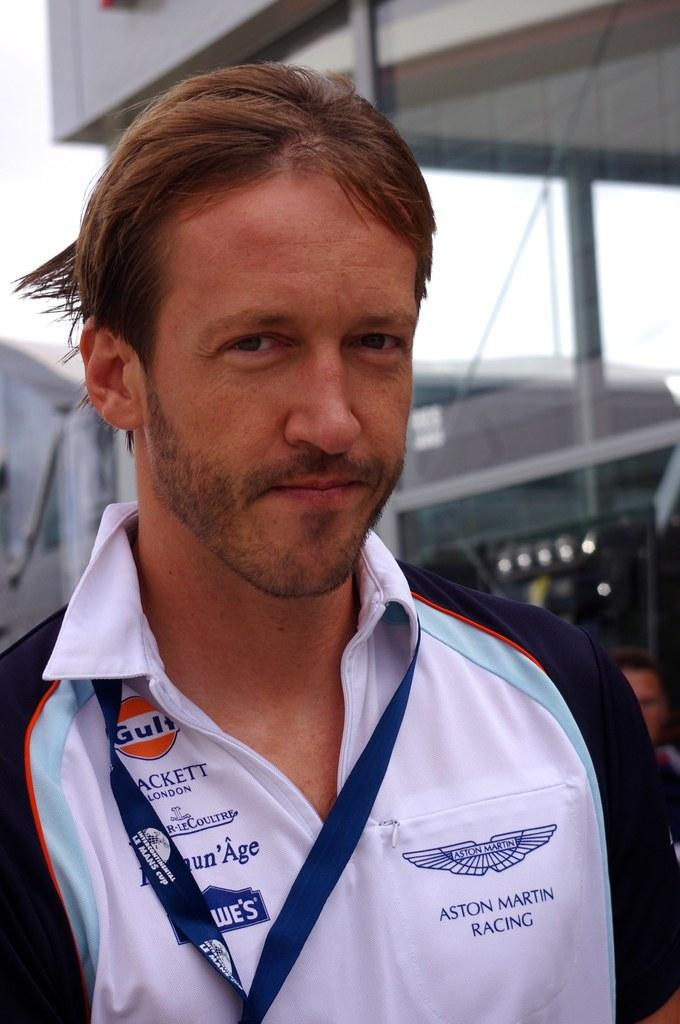<image>
Present a compact description of the photo's key features. a shirt that has the word Aston Martin Racing on it 